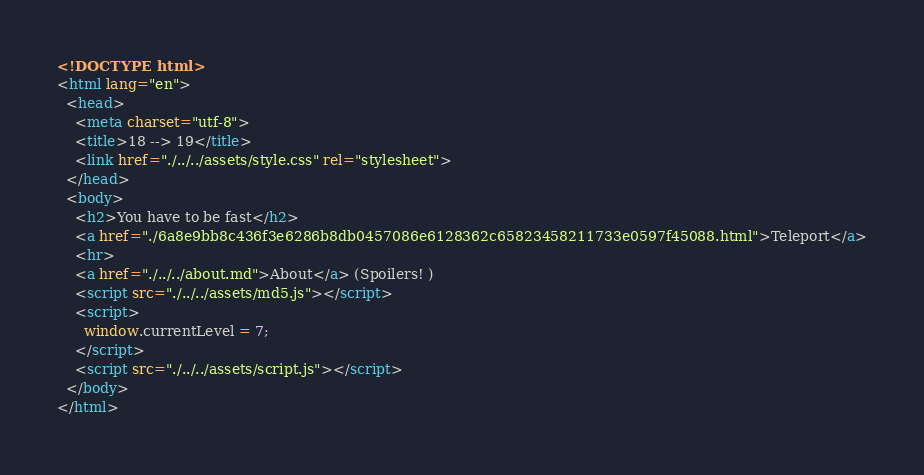Convert code to text. <code><loc_0><loc_0><loc_500><loc_500><_HTML_><!DOCTYPE html>
<html lang="en">
  <head>
    <meta charset="utf-8">
    <title>18 --> 19</title>
    <link href="./../../assets/style.css" rel="stylesheet">
  </head>
  <body>
    <h2>You have to be fast</h2>
    <a href="./6a8e9bb8c436f3e6286b8db0457086e6128362c65823458211733e0597f45088.html">Teleport</a>
    <hr>
    <a href="./../../about.md">About</a> (Spoilers! )
    <script src="./../../assets/md5.js"></script>
    <script>
      window.currentLevel = 7;
    </script>
    <script src="./../../assets/script.js"></script>
  </body>
</html></code> 